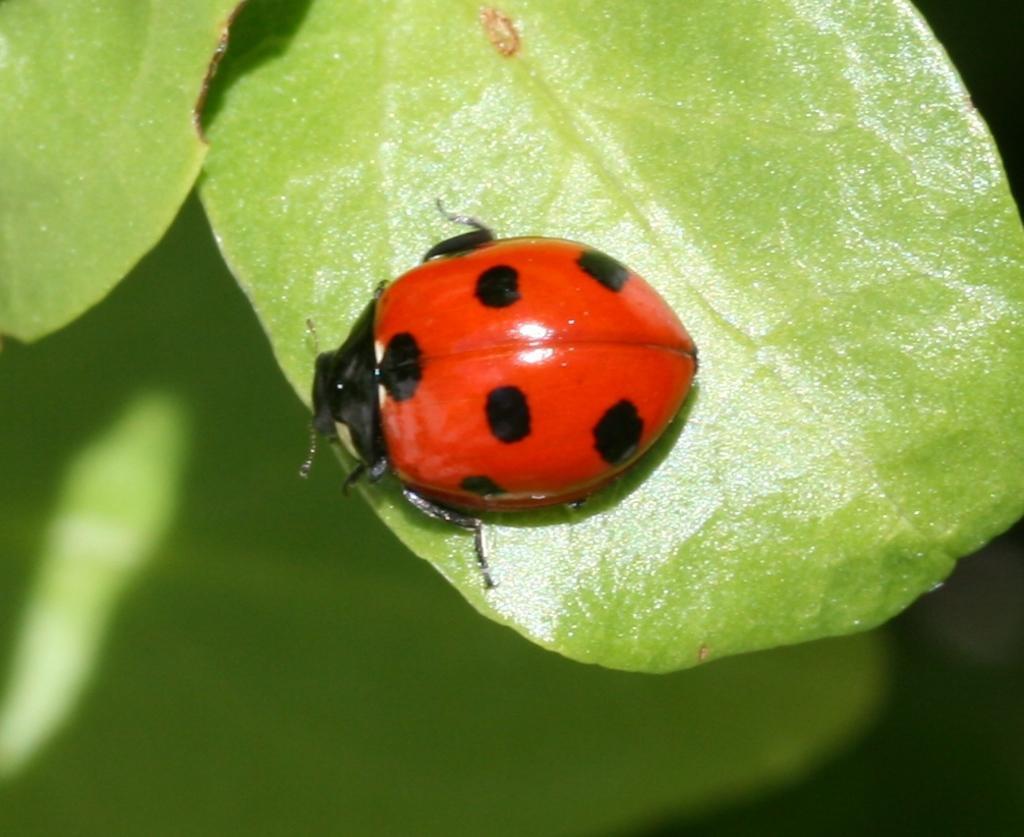Can you describe this image briefly? In this picture we can see an insect and leaves in the front, there is a blurry background. 